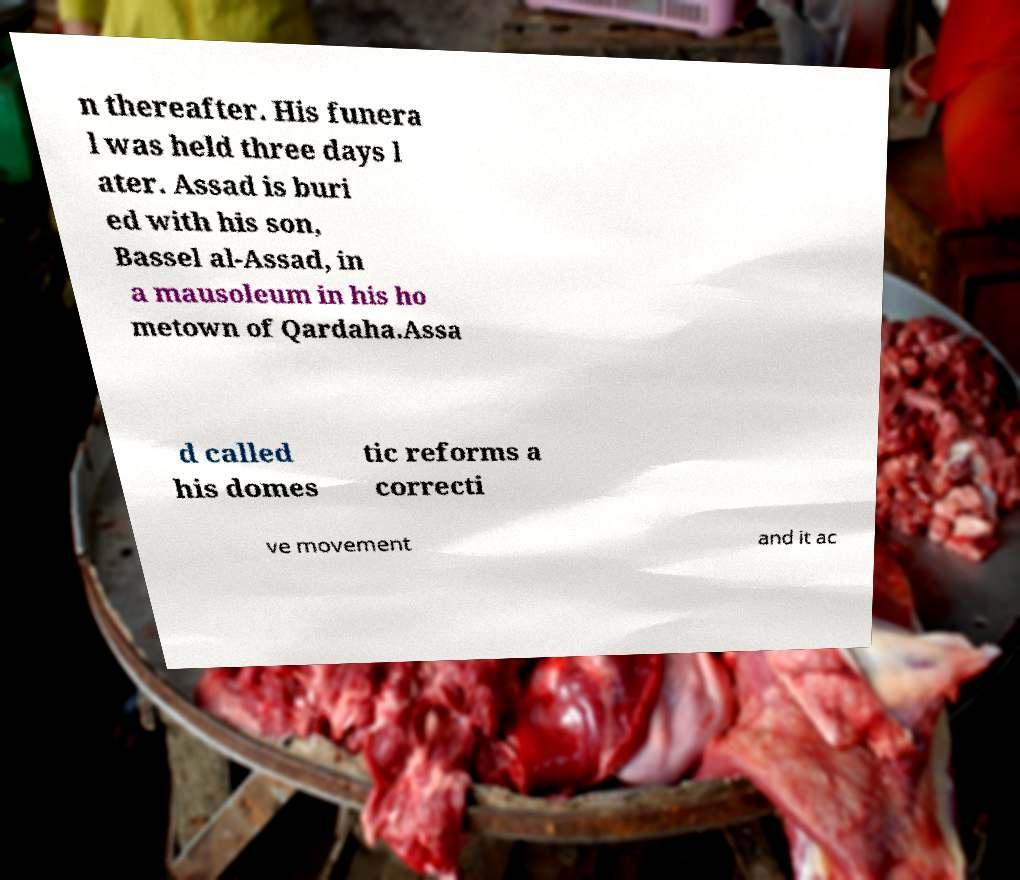Could you extract and type out the text from this image? n thereafter. His funera l was held three days l ater. Assad is buri ed with his son, Bassel al-Assad, in a mausoleum in his ho metown of Qardaha.Assa d called his domes tic reforms a correcti ve movement and it ac 